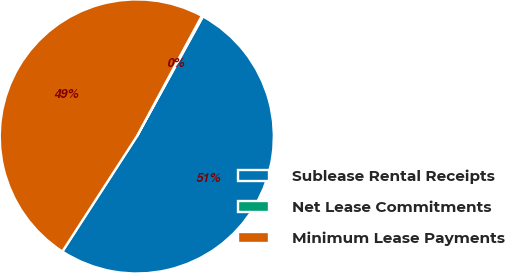<chart> <loc_0><loc_0><loc_500><loc_500><pie_chart><fcel>Sublease Rental Receipts<fcel>Net Lease Commitments<fcel>Minimum Lease Payments<nl><fcel>51.12%<fcel>0.14%<fcel>48.73%<nl></chart> 